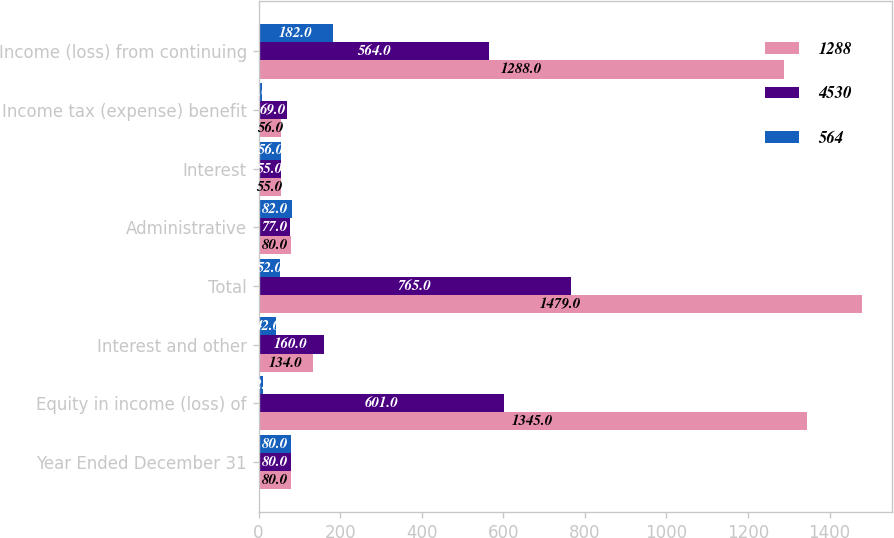Convert chart. <chart><loc_0><loc_0><loc_500><loc_500><stacked_bar_chart><ecel><fcel>Year Ended December 31<fcel>Equity in income (loss) of<fcel>Interest and other<fcel>Total<fcel>Administrative<fcel>Interest<fcel>Income tax (expense) benefit<fcel>Income (loss) from continuing<nl><fcel>1288<fcel>80<fcel>1345<fcel>134<fcel>1479<fcel>80<fcel>55<fcel>56<fcel>1288<nl><fcel>4530<fcel>80<fcel>601<fcel>160<fcel>765<fcel>77<fcel>55<fcel>69<fcel>564<nl><fcel>564<fcel>80<fcel>12<fcel>42<fcel>52<fcel>82<fcel>56<fcel>8<fcel>182<nl></chart> 